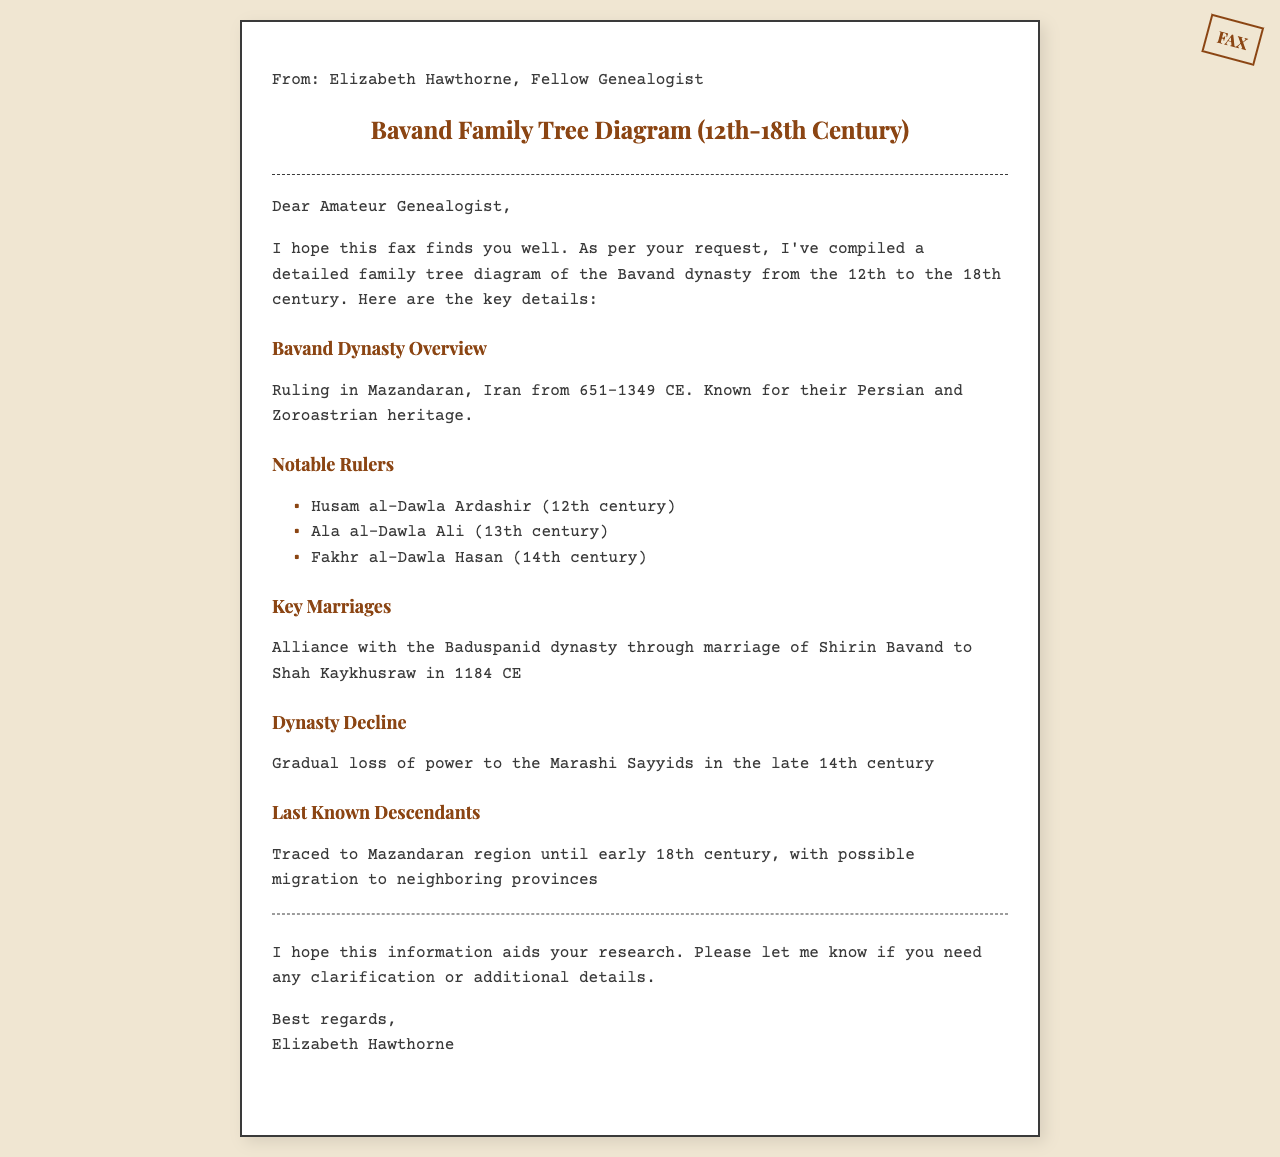What is the time period covered for the Bavand family tree? The document states that the Bavand family tree covers from the 12th to the 18th century.
Answer: 12th to the 18th century Who is the 14th-century notable ruler mentioned? The document lists Fakhr al-Dawla Hasan as a notable ruler of the 14th century.
Answer: Fakhr al-Dawla Hasan What key marriage is highlighted in the document? The fax specifies the marriage between Shirin Bavand and Shah Kaykhusraw as a significant alliance.
Answer: Shirin Bavand to Shah Kaykhusraw In which region did the Bavand dynasty rule? The document indicates that the Bavand dynasty ruled in Mazandaran, Iran.
Answer: Mazandaran, Iran What marked the decline of the Bavand dynasty? The document mentions a gradual loss of power to the Marashi Sayyids as the cause for the decline.
Answer: Loss of power to the Marashi Sayyids Who sent the fax? The document details that Elizabeth Hawthorne sent the fax as a fellow genealogist.
Answer: Elizabeth Hawthorne 